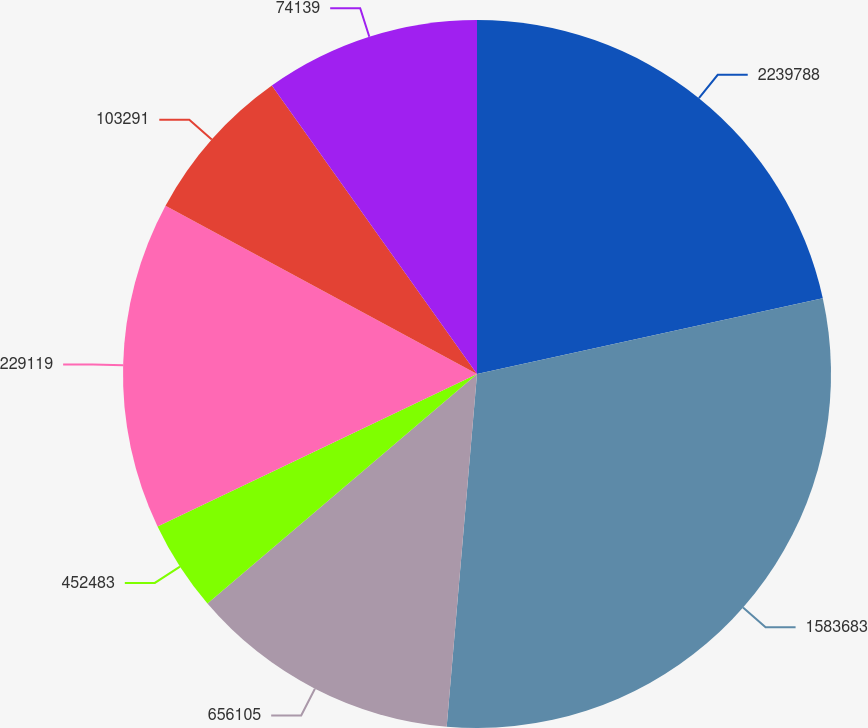Convert chart. <chart><loc_0><loc_0><loc_500><loc_500><pie_chart><fcel>2239788<fcel>1583683<fcel>656105<fcel>452483<fcel>229119<fcel>103291<fcel>74139<nl><fcel>21.57%<fcel>29.8%<fcel>12.41%<fcel>4.14%<fcel>14.97%<fcel>7.28%<fcel>9.84%<nl></chart> 